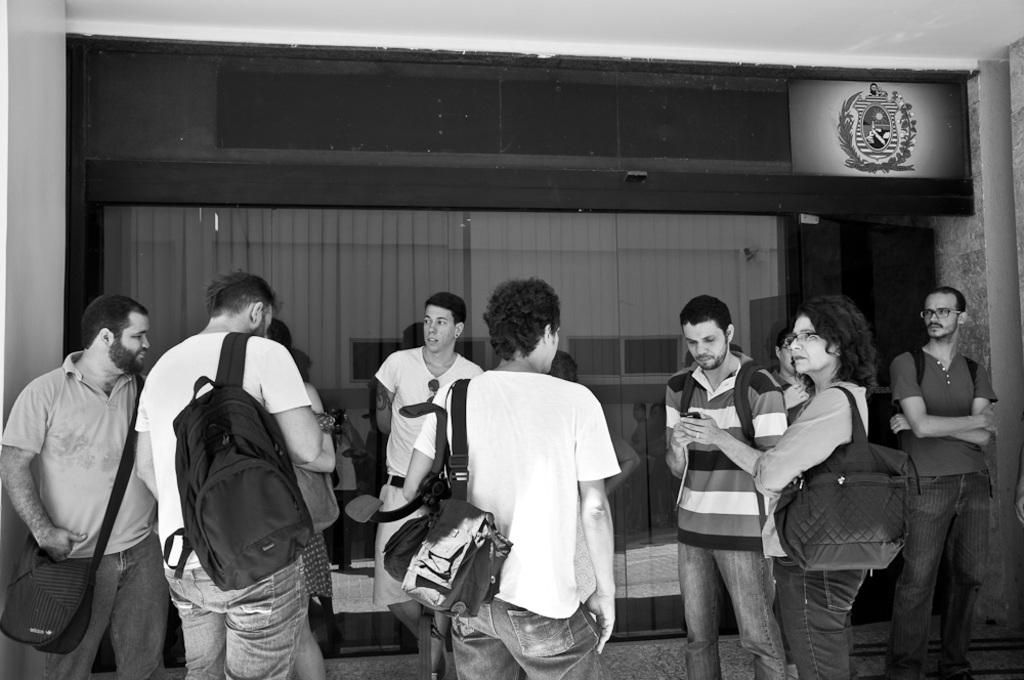Who or what can be seen in the image? There are people in the image. What is the setting or location of the people? The people are standing in front of a cabin. Can you describe any accessories or items the people are wearing? Some people in the image are wearing bags. What part of the cabin can be seen in the image? There is a ceiling visible at the top of the image. What type of cheese is being used to make the wheel in the image? There is no cheese or wheel present in the image. 